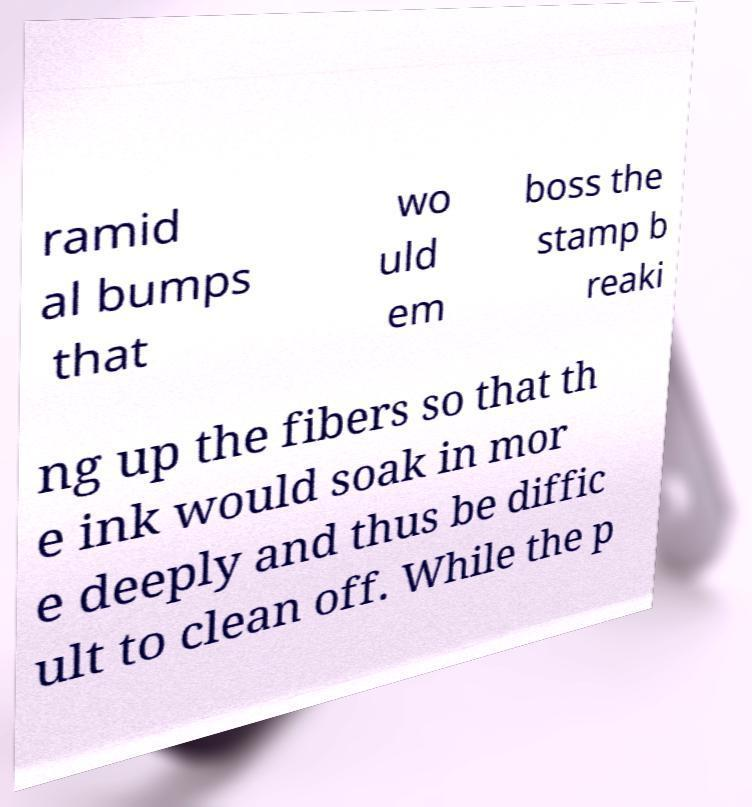There's text embedded in this image that I need extracted. Can you transcribe it verbatim? ramid al bumps that wo uld em boss the stamp b reaki ng up the fibers so that th e ink would soak in mor e deeply and thus be diffic ult to clean off. While the p 